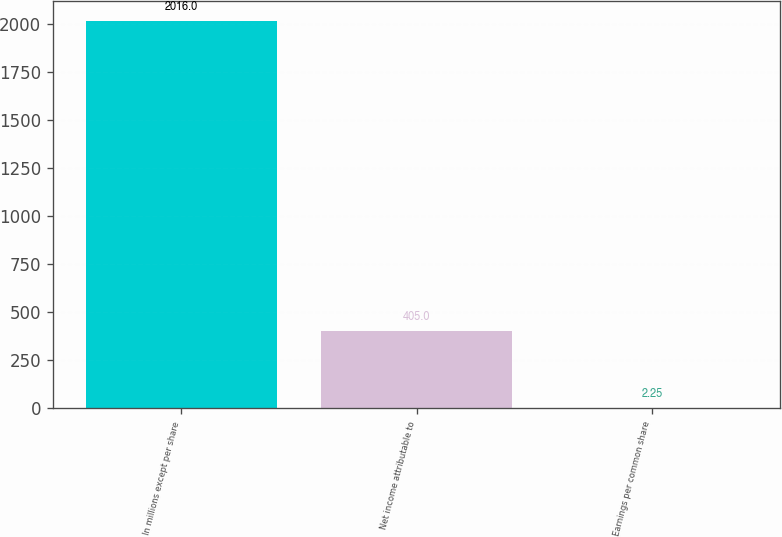Convert chart to OTSL. <chart><loc_0><loc_0><loc_500><loc_500><bar_chart><fcel>In millions except per share<fcel>Net income attributable to<fcel>Earnings per common share<nl><fcel>2016<fcel>405<fcel>2.25<nl></chart> 